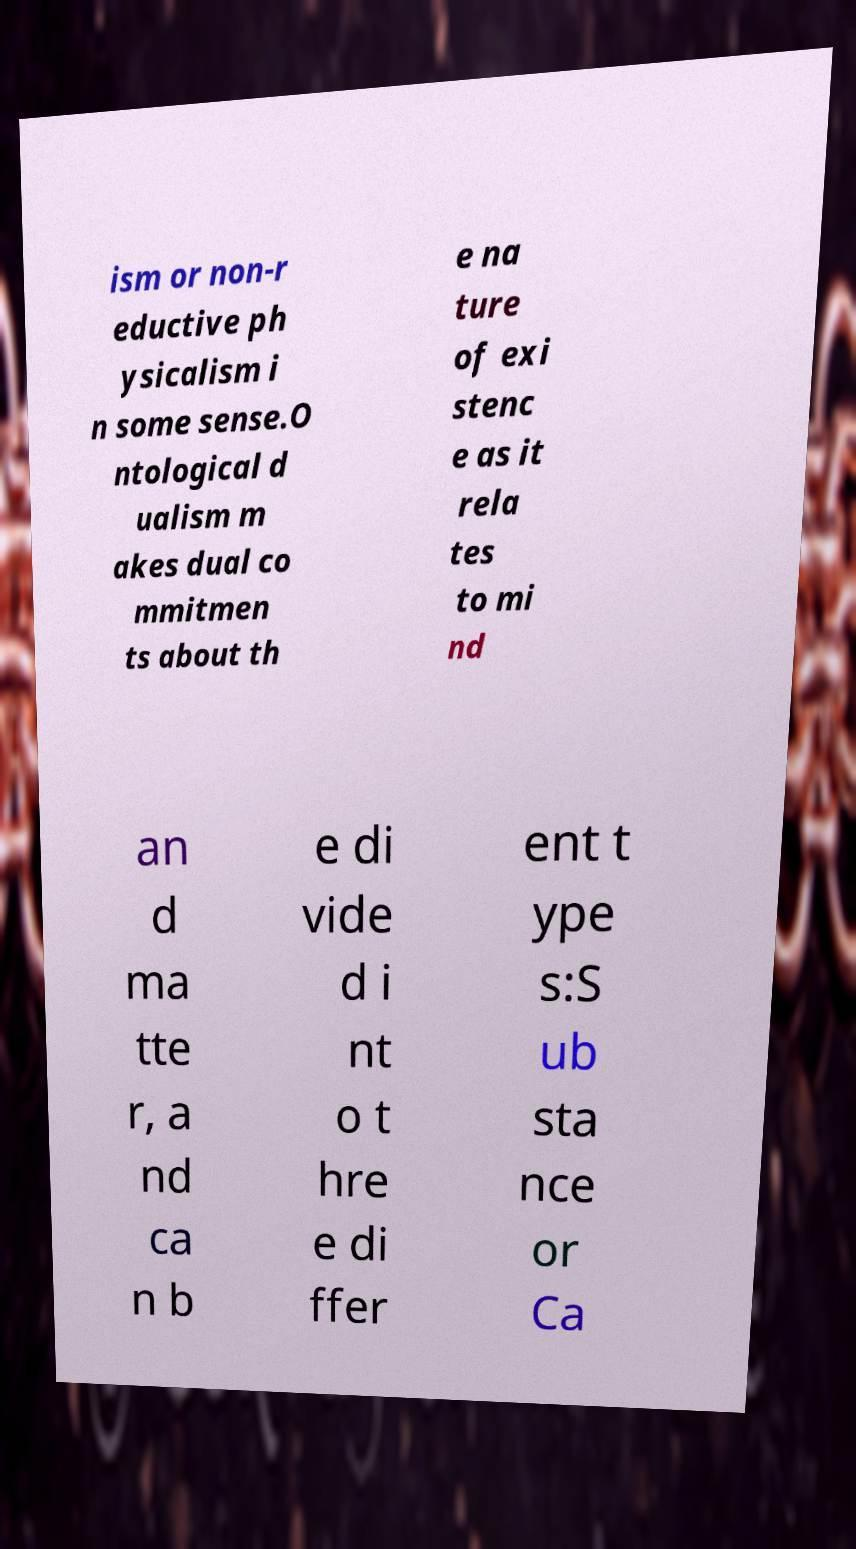Can you read and provide the text displayed in the image?This photo seems to have some interesting text. Can you extract and type it out for me? ism or non-r eductive ph ysicalism i n some sense.O ntological d ualism m akes dual co mmitmen ts about th e na ture of exi stenc e as it rela tes to mi nd an d ma tte r, a nd ca n b e di vide d i nt o t hre e di ffer ent t ype s:S ub sta nce or Ca 